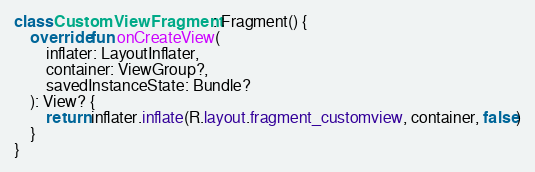Convert code to text. <code><loc_0><loc_0><loc_500><loc_500><_Kotlin_>class CustomViewFragment : Fragment() {
    override fun onCreateView(
        inflater: LayoutInflater,
        container: ViewGroup?,
        savedInstanceState: Bundle?
    ): View? {
        return inflater.inflate(R.layout.fragment_customview, container, false)
    }
}</code> 